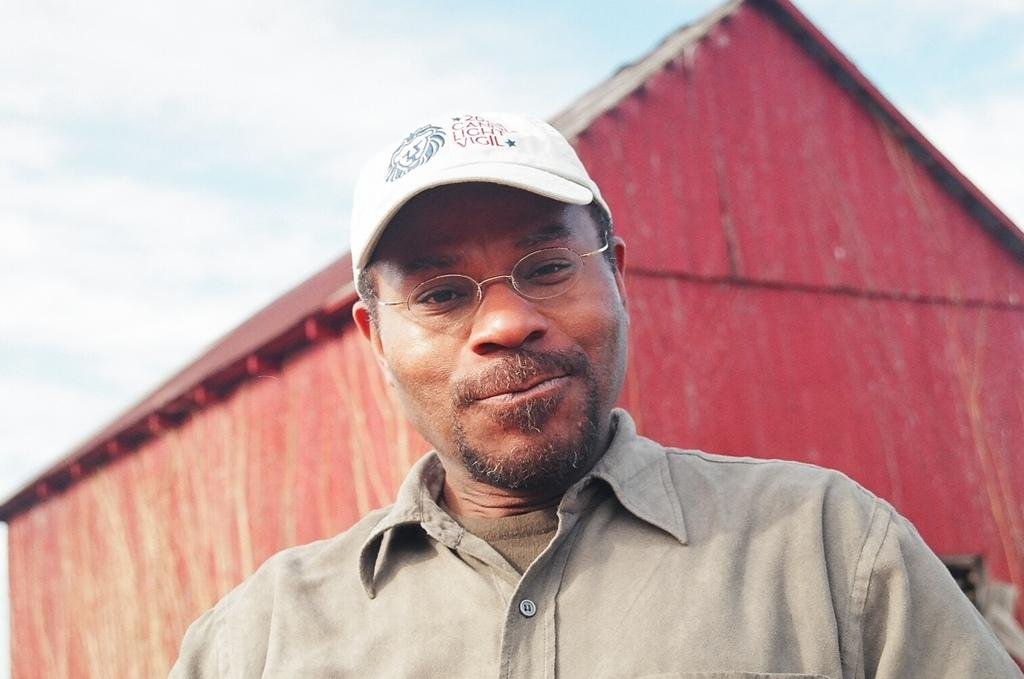What is the main subject of the image? There is a person standing in the middle of the image. What is the person wearing on their head? The person is wearing a cap. What can be seen in the background of the image? There is a house visible in the background of the image. What type of honey is being collected by the fowl in the image? There is no honey or fowl present in the image. What view can be seen from the person's perspective in the image? The provided facts do not give information about the person's perspective or the view they might have. 